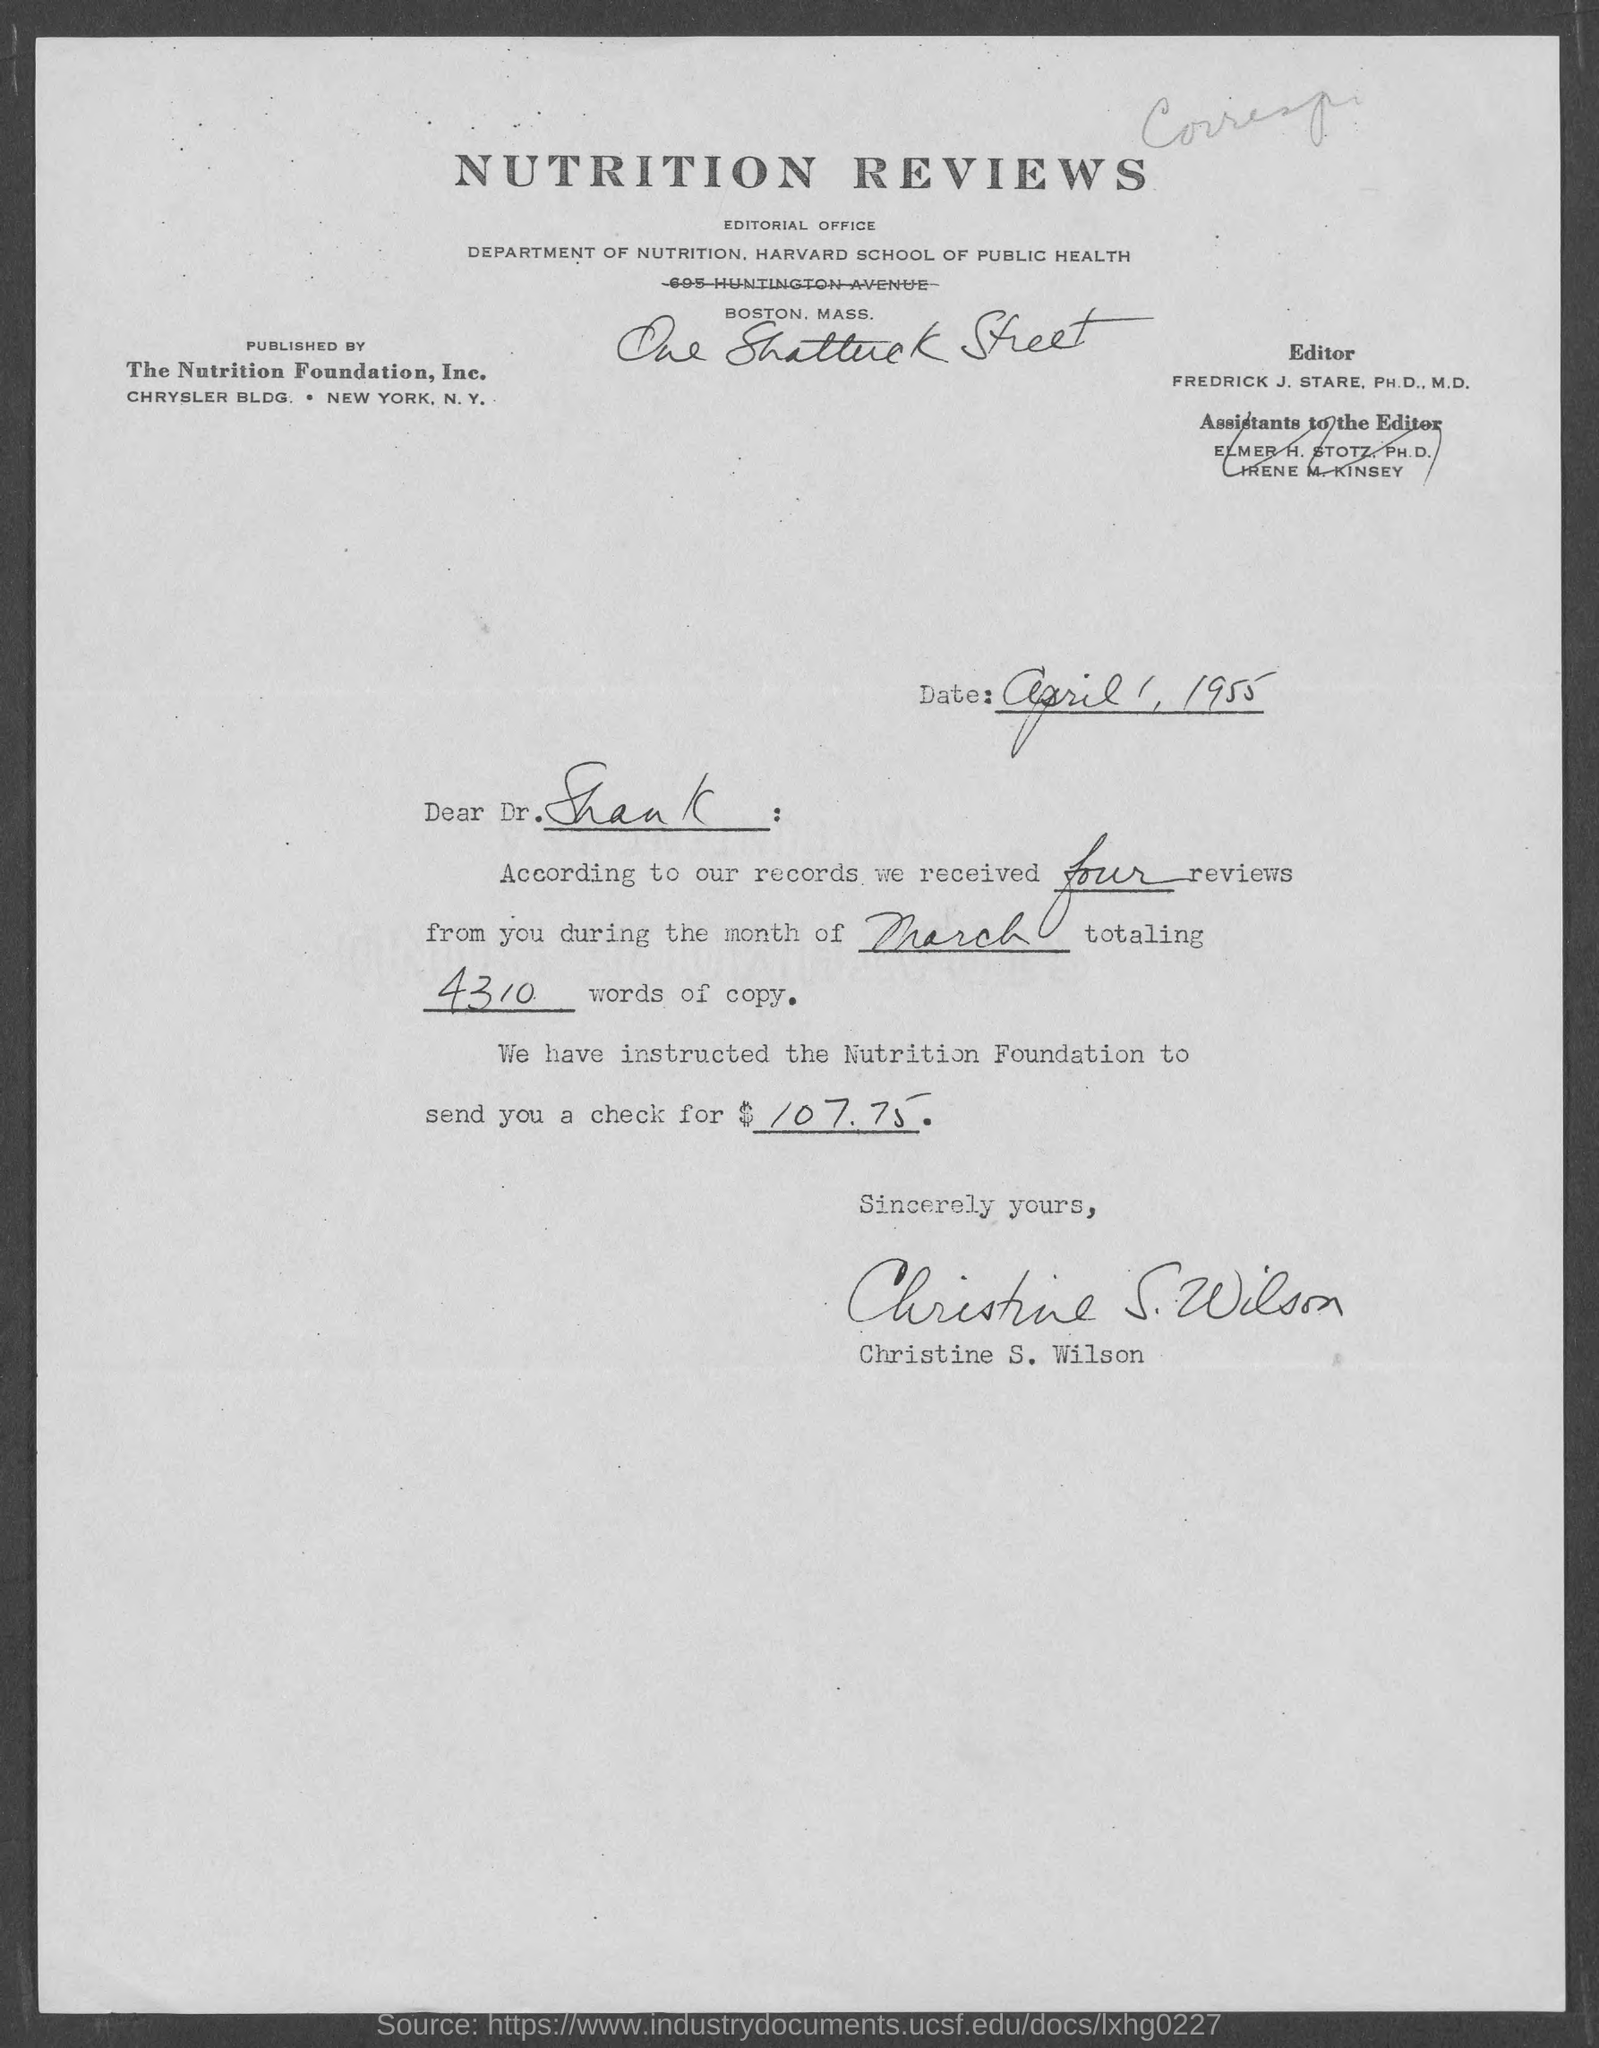What is the date mentioned ?
Your answer should be very brief. APRIL 1, 1955. To whom this letter is sent ?
Keep it short and to the point. Dr. Shank. According to  their records how many reviews did they receive ?
Offer a terse response. FOUR. According to our records we received four reviews from you during the month of march totaling how many words of copy
Provide a succinct answer. 4310. This letter is written by whom ?
Your answer should be very brief. Christine S. wilson. 